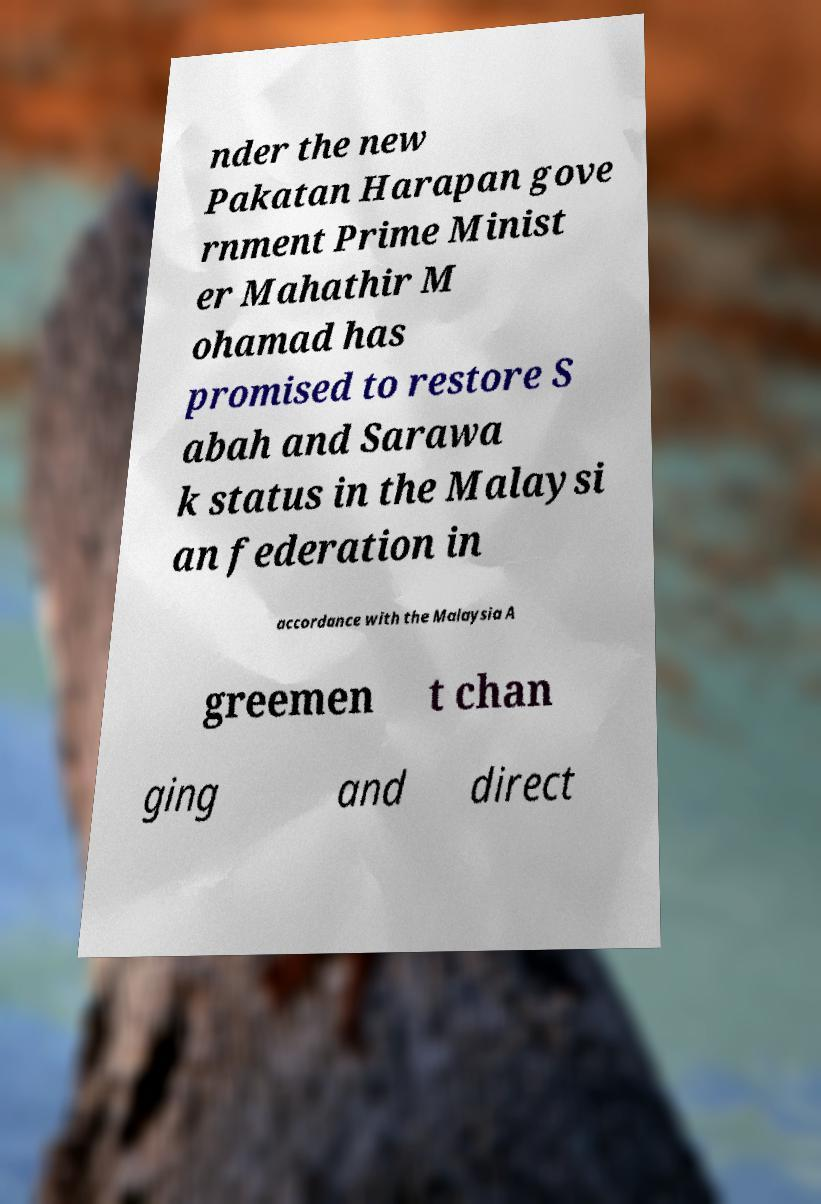Could you assist in decoding the text presented in this image and type it out clearly? nder the new Pakatan Harapan gove rnment Prime Minist er Mahathir M ohamad has promised to restore S abah and Sarawa k status in the Malaysi an federation in accordance with the Malaysia A greemen t chan ging and direct 